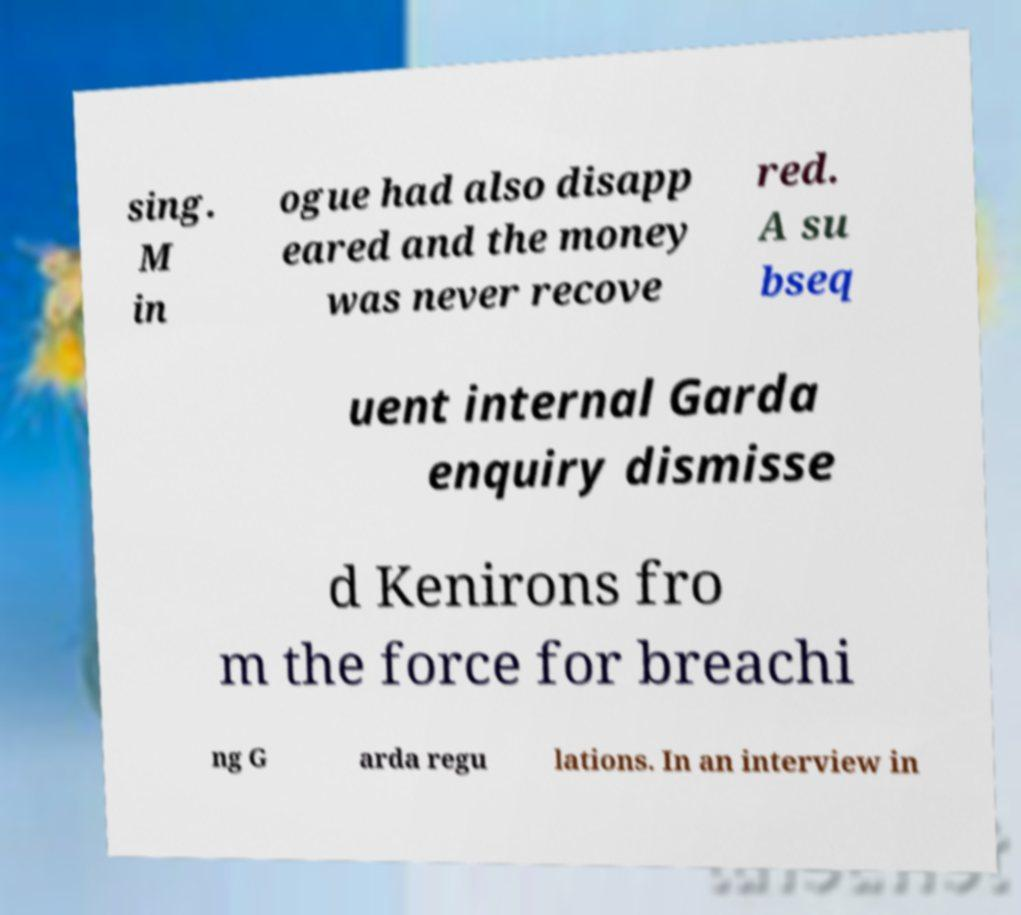I need the written content from this picture converted into text. Can you do that? sing. M in ogue had also disapp eared and the money was never recove red. A su bseq uent internal Garda enquiry dismisse d Kenirons fro m the force for breachi ng G arda regu lations. In an interview in 